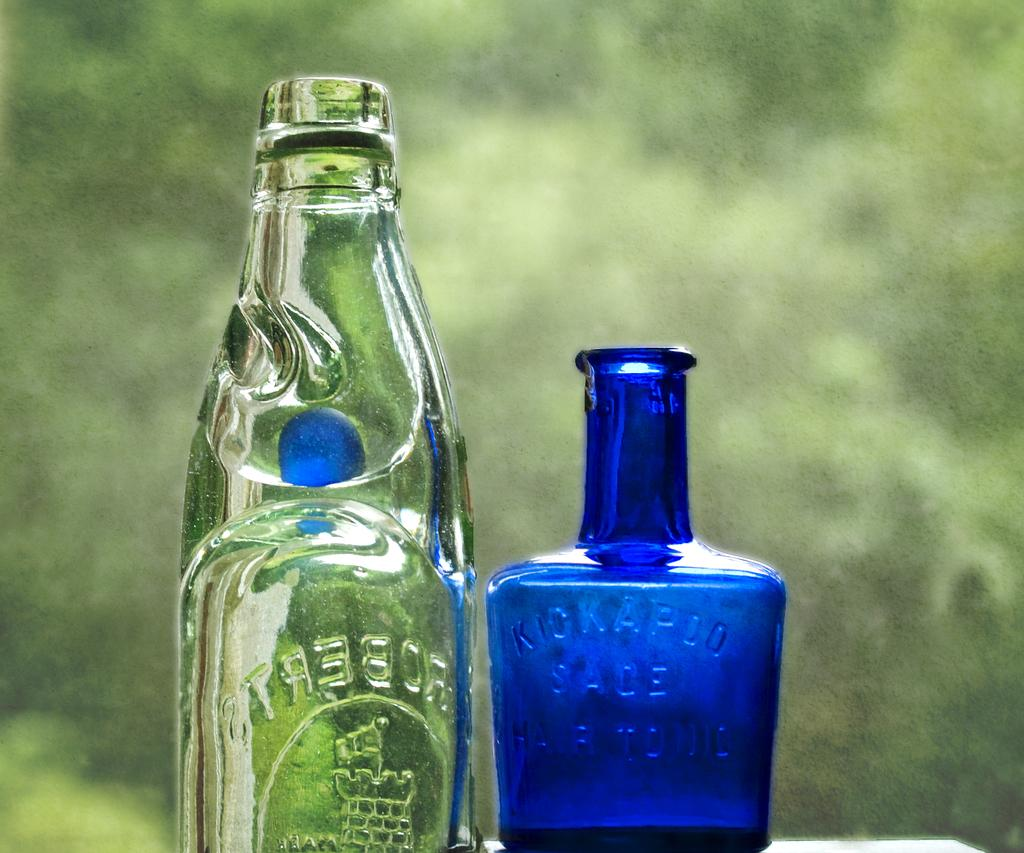<image>
Create a compact narrative representing the image presented. A clear glass bottle and a blue bottle with kickapoo engraved on it. 